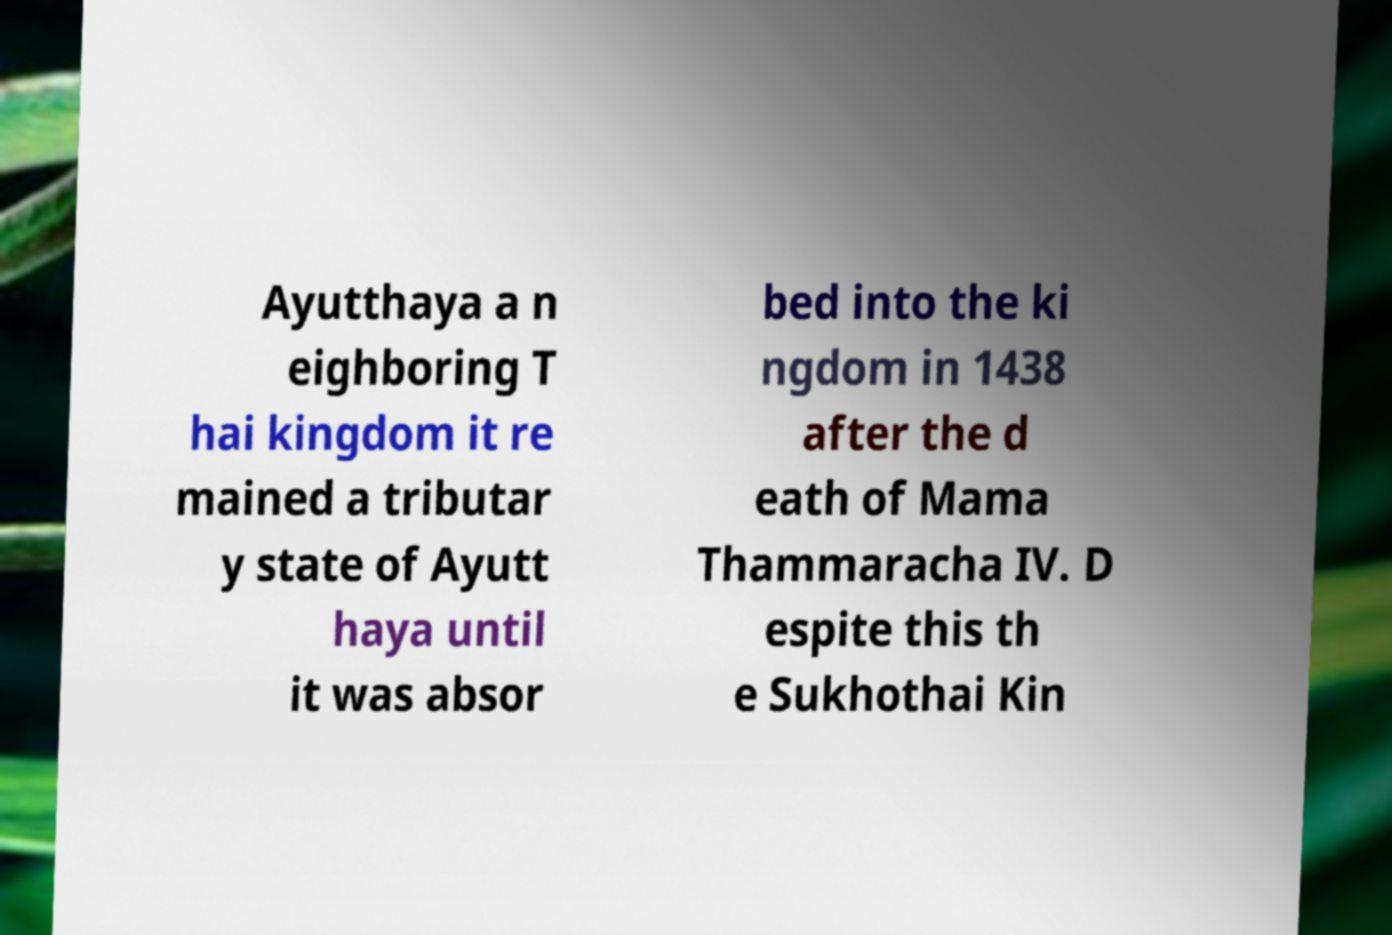Please read and relay the text visible in this image. What does it say? Ayutthaya a n eighboring T hai kingdom it re mained a tributar y state of Ayutt haya until it was absor bed into the ki ngdom in 1438 after the d eath of Mama Thammaracha IV. D espite this th e Sukhothai Kin 